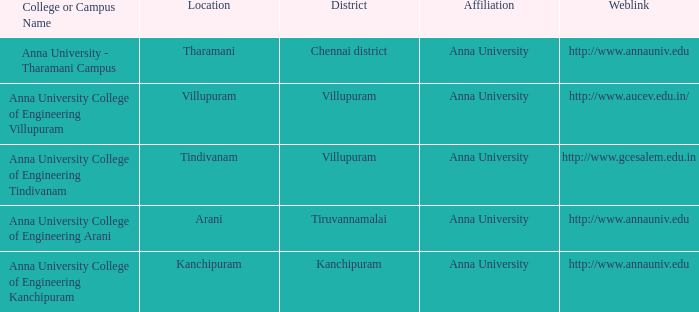What district is home to a college or campus known as anna university college of engineering kanchipuram? Kanchipuram. Can you give me this table as a dict? {'header': ['College or Campus Name', 'Location', 'District', 'Affiliation', 'Weblink'], 'rows': [['Anna University - Tharamani Campus', 'Tharamani', 'Chennai district', 'Anna University', 'http://www.annauniv.edu'], ['Anna University College of Engineering Villupuram', 'Villupuram', 'Villupuram', 'Anna University', 'http://www.aucev.edu.in/'], ['Anna University College of Engineering Tindivanam', 'Tindivanam', 'Villupuram', 'Anna University', 'http://www.gcesalem.edu.in'], ['Anna University College of Engineering Arani', 'Arani', 'Tiruvannamalai', 'Anna University', 'http://www.annauniv.edu'], ['Anna University College of Engineering Kanchipuram', 'Kanchipuram', 'Kanchipuram', 'Anna University', 'http://www.annauniv.edu']]} 